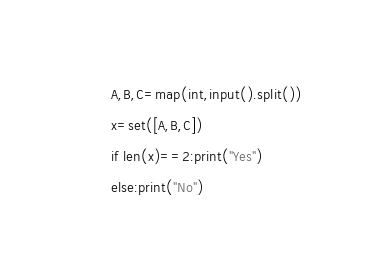Convert code to text. <code><loc_0><loc_0><loc_500><loc_500><_Python_>A,B,C=map(int,input().split())
x=set([A,B,C])
if len(x)==2:print("Yes")
else:print("No")</code> 